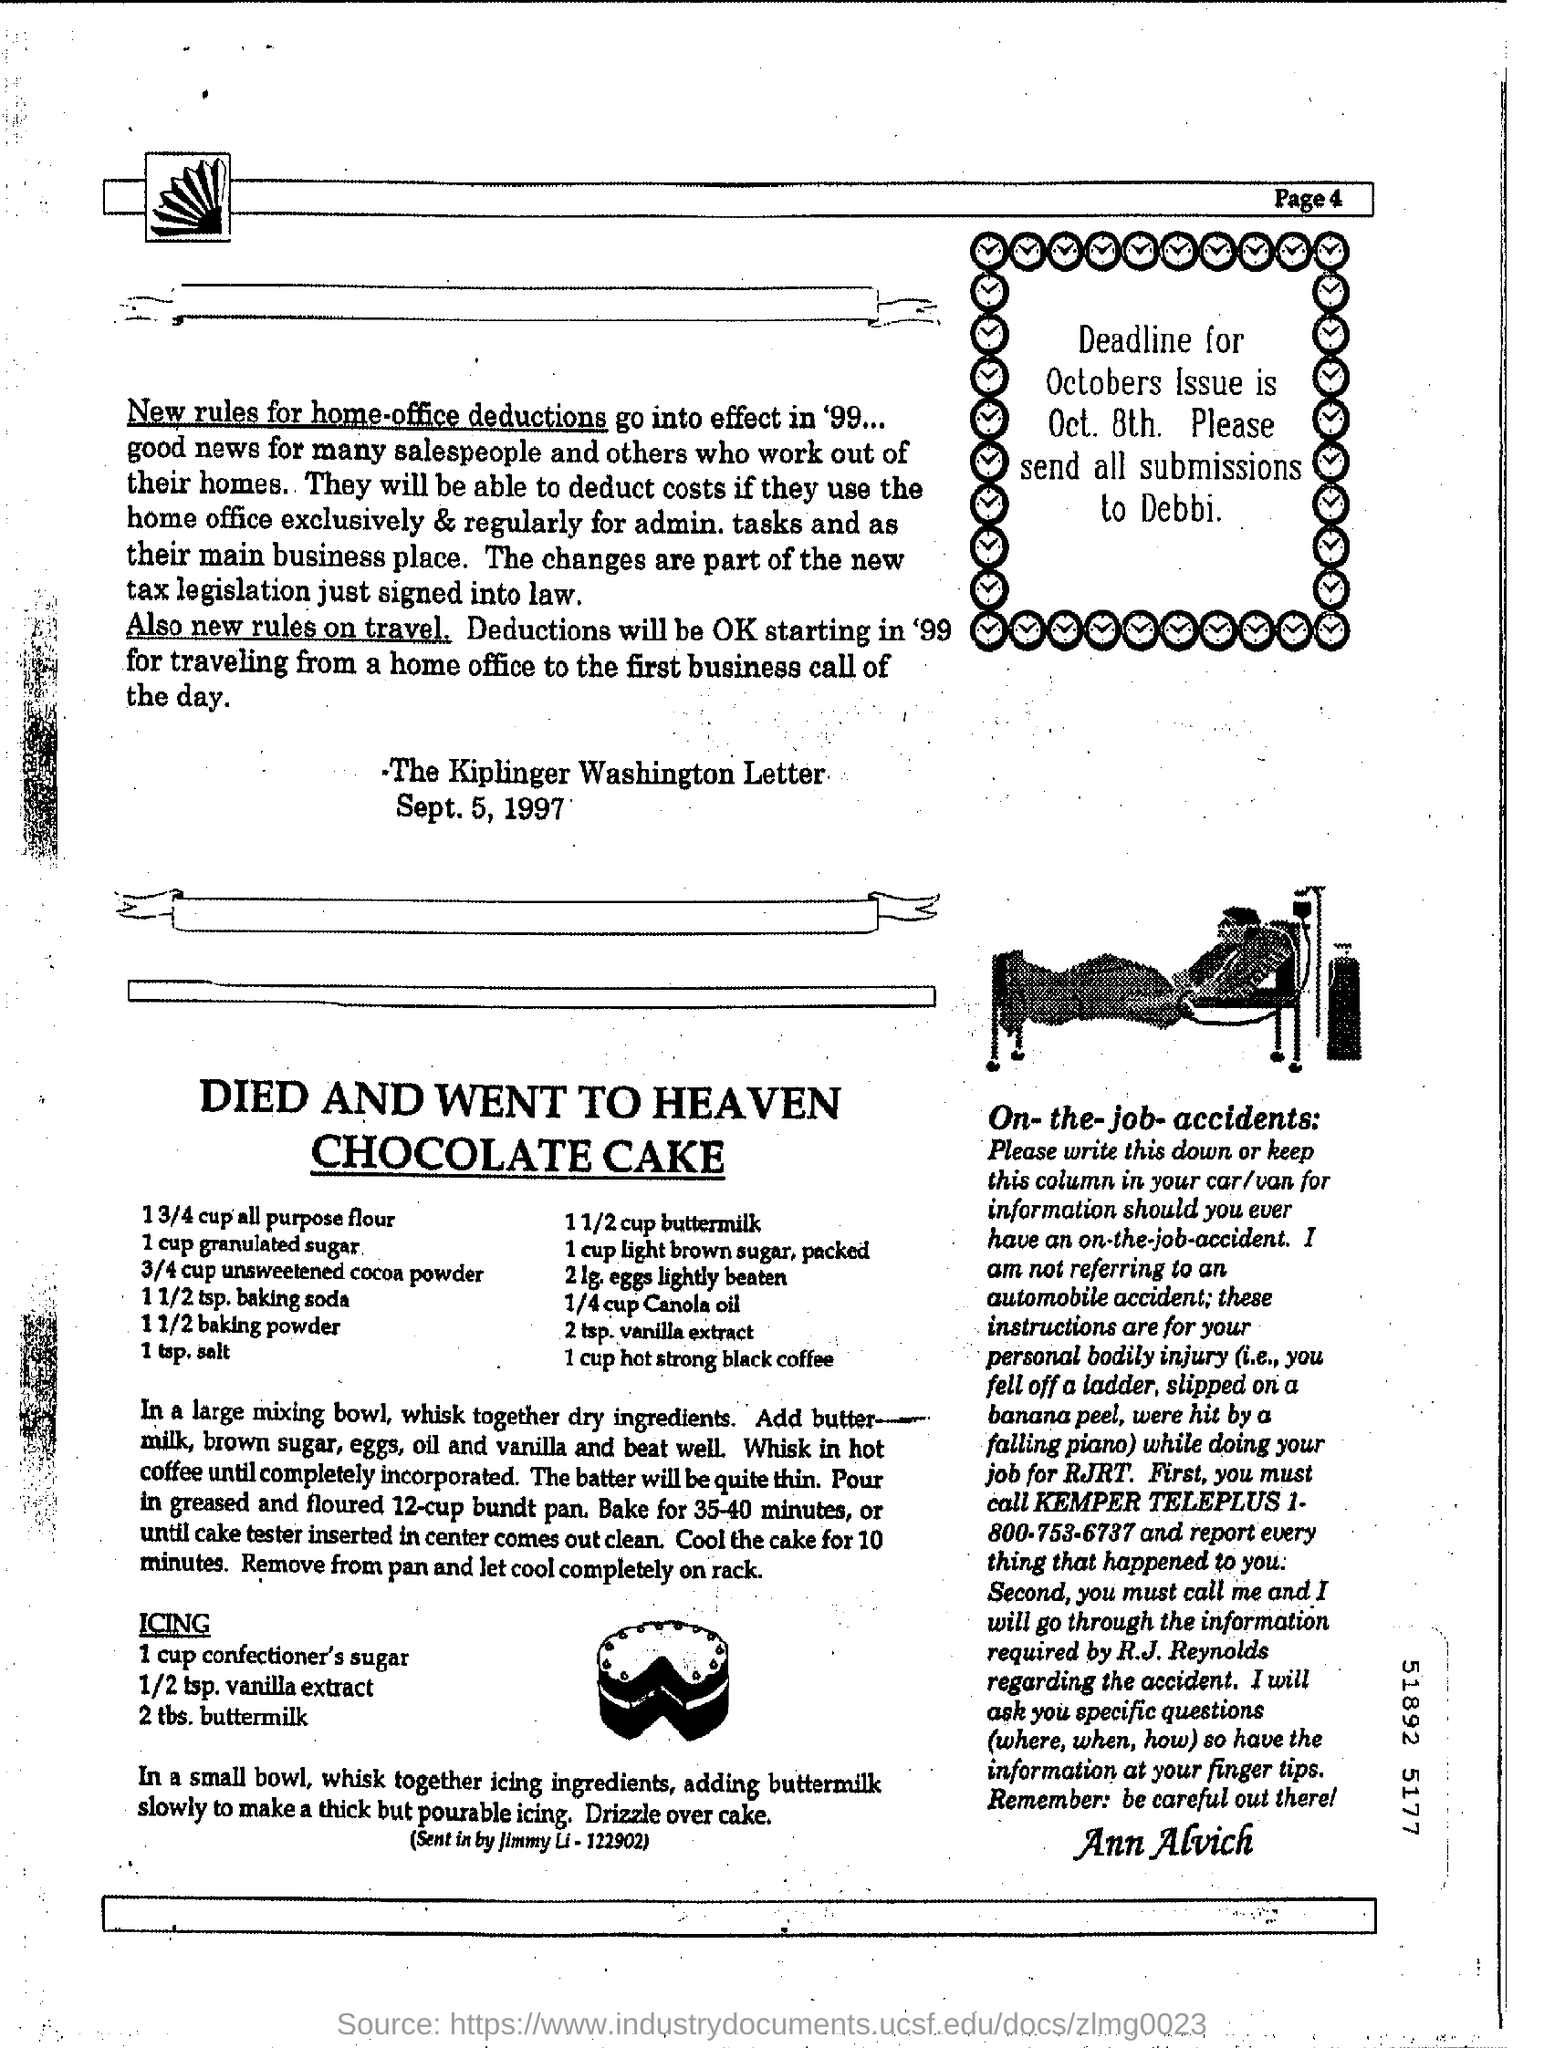Highlight a few significant elements in this photo. Please mention the page number at the top right corner of the page, starting with page 4. 